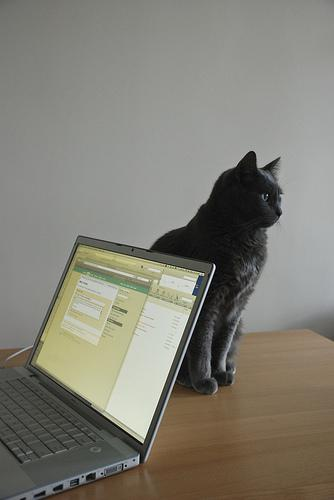Question: what is sitting on the table with the cat?
Choices:
A. Flower vase.
B. Keyboard.
C. Computer.
D. Book.
Answer with the letter. Answer: C Question: what type of computer is on the table?
Choices:
A. Laptop.
B. Desktop.
C. Gaming console.
D. Tablet.
Answer with the letter. Answer: A Question: what is the table made of?
Choices:
A. Plastic.
B. Wood.
C. Metal.
D. Glass.
Answer with the letter. Answer: B Question: what kind of animal is in the picture?
Choices:
A. A horse.
B. A dog.
C. A cat.
D. A pig.
Answer with the letter. Answer: C 